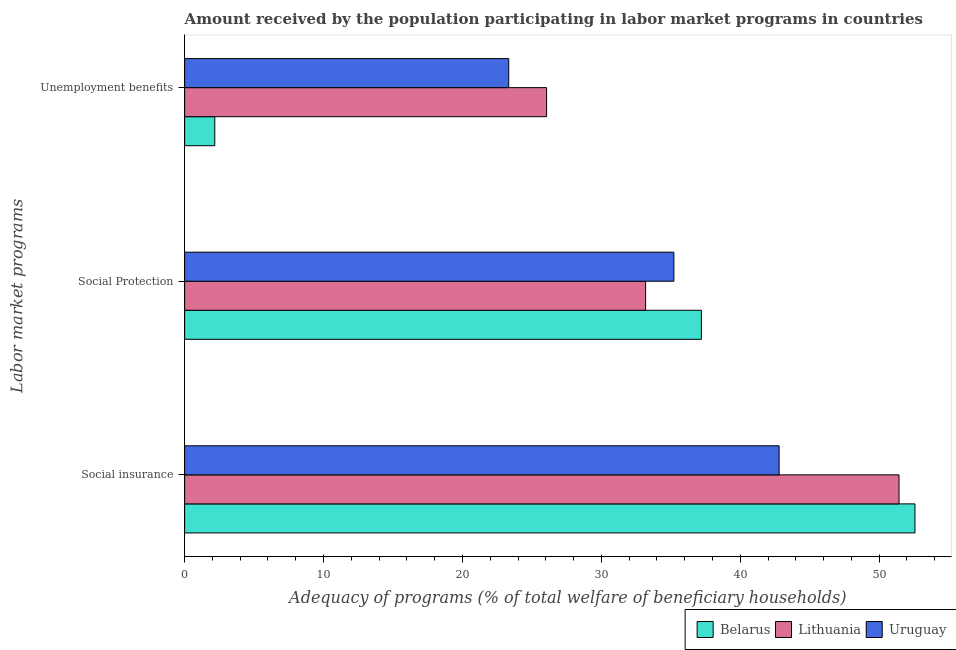How many different coloured bars are there?
Your response must be concise. 3. Are the number of bars per tick equal to the number of legend labels?
Your answer should be very brief. Yes. Are the number of bars on each tick of the Y-axis equal?
Make the answer very short. Yes. How many bars are there on the 2nd tick from the top?
Your answer should be compact. 3. What is the label of the 1st group of bars from the top?
Provide a short and direct response. Unemployment benefits. What is the amount received by the population participating in unemployment benefits programs in Belarus?
Your answer should be very brief. 2.17. Across all countries, what is the maximum amount received by the population participating in social protection programs?
Keep it short and to the point. 37.2. Across all countries, what is the minimum amount received by the population participating in social protection programs?
Offer a terse response. 33.19. In which country was the amount received by the population participating in social insurance programs maximum?
Keep it short and to the point. Belarus. In which country was the amount received by the population participating in social protection programs minimum?
Offer a terse response. Lithuania. What is the total amount received by the population participating in social protection programs in the graph?
Offer a terse response. 105.61. What is the difference between the amount received by the population participating in unemployment benefits programs in Belarus and that in Uruguay?
Ensure brevity in your answer.  -21.16. What is the difference between the amount received by the population participating in unemployment benefits programs in Lithuania and the amount received by the population participating in social insurance programs in Uruguay?
Your answer should be very brief. -16.74. What is the average amount received by the population participating in social protection programs per country?
Make the answer very short. 35.2. What is the difference between the amount received by the population participating in social insurance programs and amount received by the population participating in unemployment benefits programs in Lithuania?
Provide a short and direct response. 25.37. What is the ratio of the amount received by the population participating in social protection programs in Uruguay to that in Lithuania?
Your response must be concise. 1.06. Is the difference between the amount received by the population participating in social insurance programs in Belarus and Uruguay greater than the difference between the amount received by the population participating in unemployment benefits programs in Belarus and Uruguay?
Your response must be concise. Yes. What is the difference between the highest and the second highest amount received by the population participating in social insurance programs?
Provide a succinct answer. 1.15. What is the difference between the highest and the lowest amount received by the population participating in unemployment benefits programs?
Your answer should be compact. 23.89. In how many countries, is the amount received by the population participating in social insurance programs greater than the average amount received by the population participating in social insurance programs taken over all countries?
Offer a very short reply. 2. What does the 1st bar from the top in Social insurance represents?
Make the answer very short. Uruguay. What does the 3rd bar from the bottom in Social insurance represents?
Your answer should be very brief. Uruguay. Is it the case that in every country, the sum of the amount received by the population participating in social insurance programs and amount received by the population participating in social protection programs is greater than the amount received by the population participating in unemployment benefits programs?
Offer a terse response. Yes. Are all the bars in the graph horizontal?
Your answer should be very brief. Yes. What is the difference between two consecutive major ticks on the X-axis?
Ensure brevity in your answer.  10. Does the graph contain any zero values?
Your answer should be compact. No. How many legend labels are there?
Make the answer very short. 3. How are the legend labels stacked?
Provide a succinct answer. Horizontal. What is the title of the graph?
Your answer should be compact. Amount received by the population participating in labor market programs in countries. Does "OECD members" appear as one of the legend labels in the graph?
Keep it short and to the point. No. What is the label or title of the X-axis?
Your response must be concise. Adequacy of programs (% of total welfare of beneficiary households). What is the label or title of the Y-axis?
Your response must be concise. Labor market programs. What is the Adequacy of programs (% of total welfare of beneficiary households) in Belarus in Social insurance?
Offer a very short reply. 52.58. What is the Adequacy of programs (% of total welfare of beneficiary households) of Lithuania in Social insurance?
Ensure brevity in your answer.  51.43. What is the Adequacy of programs (% of total welfare of beneficiary households) of Uruguay in Social insurance?
Make the answer very short. 42.8. What is the Adequacy of programs (% of total welfare of beneficiary households) in Belarus in Social Protection?
Offer a very short reply. 37.2. What is the Adequacy of programs (% of total welfare of beneficiary households) of Lithuania in Social Protection?
Your response must be concise. 33.19. What is the Adequacy of programs (% of total welfare of beneficiary households) of Uruguay in Social Protection?
Provide a short and direct response. 35.22. What is the Adequacy of programs (% of total welfare of beneficiary households) of Belarus in Unemployment benefits?
Your answer should be very brief. 2.17. What is the Adequacy of programs (% of total welfare of beneficiary households) in Lithuania in Unemployment benefits?
Provide a succinct answer. 26.06. What is the Adequacy of programs (% of total welfare of beneficiary households) in Uruguay in Unemployment benefits?
Ensure brevity in your answer.  23.33. Across all Labor market programs, what is the maximum Adequacy of programs (% of total welfare of beneficiary households) of Belarus?
Provide a short and direct response. 52.58. Across all Labor market programs, what is the maximum Adequacy of programs (% of total welfare of beneficiary households) of Lithuania?
Your answer should be compact. 51.43. Across all Labor market programs, what is the maximum Adequacy of programs (% of total welfare of beneficiary households) in Uruguay?
Make the answer very short. 42.8. Across all Labor market programs, what is the minimum Adequacy of programs (% of total welfare of beneficiary households) in Belarus?
Give a very brief answer. 2.17. Across all Labor market programs, what is the minimum Adequacy of programs (% of total welfare of beneficiary households) in Lithuania?
Provide a succinct answer. 26.06. Across all Labor market programs, what is the minimum Adequacy of programs (% of total welfare of beneficiary households) of Uruguay?
Provide a succinct answer. 23.33. What is the total Adequacy of programs (% of total welfare of beneficiary households) in Belarus in the graph?
Your answer should be compact. 91.95. What is the total Adequacy of programs (% of total welfare of beneficiary households) of Lithuania in the graph?
Your response must be concise. 110.68. What is the total Adequacy of programs (% of total welfare of beneficiary households) in Uruguay in the graph?
Make the answer very short. 101.35. What is the difference between the Adequacy of programs (% of total welfare of beneficiary households) in Belarus in Social insurance and that in Social Protection?
Your answer should be compact. 15.38. What is the difference between the Adequacy of programs (% of total welfare of beneficiary households) of Lithuania in Social insurance and that in Social Protection?
Make the answer very short. 18.24. What is the difference between the Adequacy of programs (% of total welfare of beneficiary households) in Uruguay in Social insurance and that in Social Protection?
Make the answer very short. 7.58. What is the difference between the Adequacy of programs (% of total welfare of beneficiary households) of Belarus in Social insurance and that in Unemployment benefits?
Offer a very short reply. 50.41. What is the difference between the Adequacy of programs (% of total welfare of beneficiary households) of Lithuania in Social insurance and that in Unemployment benefits?
Ensure brevity in your answer.  25.37. What is the difference between the Adequacy of programs (% of total welfare of beneficiary households) in Uruguay in Social insurance and that in Unemployment benefits?
Your answer should be very brief. 19.47. What is the difference between the Adequacy of programs (% of total welfare of beneficiary households) of Belarus in Social Protection and that in Unemployment benefits?
Ensure brevity in your answer.  35.03. What is the difference between the Adequacy of programs (% of total welfare of beneficiary households) of Lithuania in Social Protection and that in Unemployment benefits?
Your response must be concise. 7.13. What is the difference between the Adequacy of programs (% of total welfare of beneficiary households) in Uruguay in Social Protection and that in Unemployment benefits?
Offer a terse response. 11.89. What is the difference between the Adequacy of programs (% of total welfare of beneficiary households) in Belarus in Social insurance and the Adequacy of programs (% of total welfare of beneficiary households) in Lithuania in Social Protection?
Provide a succinct answer. 19.39. What is the difference between the Adequacy of programs (% of total welfare of beneficiary households) in Belarus in Social insurance and the Adequacy of programs (% of total welfare of beneficiary households) in Uruguay in Social Protection?
Ensure brevity in your answer.  17.36. What is the difference between the Adequacy of programs (% of total welfare of beneficiary households) in Lithuania in Social insurance and the Adequacy of programs (% of total welfare of beneficiary households) in Uruguay in Social Protection?
Keep it short and to the point. 16.21. What is the difference between the Adequacy of programs (% of total welfare of beneficiary households) of Belarus in Social insurance and the Adequacy of programs (% of total welfare of beneficiary households) of Lithuania in Unemployment benefits?
Offer a very short reply. 26.52. What is the difference between the Adequacy of programs (% of total welfare of beneficiary households) of Belarus in Social insurance and the Adequacy of programs (% of total welfare of beneficiary households) of Uruguay in Unemployment benefits?
Your answer should be compact. 29.25. What is the difference between the Adequacy of programs (% of total welfare of beneficiary households) in Lithuania in Social insurance and the Adequacy of programs (% of total welfare of beneficiary households) in Uruguay in Unemployment benefits?
Ensure brevity in your answer.  28.1. What is the difference between the Adequacy of programs (% of total welfare of beneficiary households) in Belarus in Social Protection and the Adequacy of programs (% of total welfare of beneficiary households) in Lithuania in Unemployment benefits?
Offer a terse response. 11.14. What is the difference between the Adequacy of programs (% of total welfare of beneficiary households) in Belarus in Social Protection and the Adequacy of programs (% of total welfare of beneficiary households) in Uruguay in Unemployment benefits?
Offer a very short reply. 13.87. What is the difference between the Adequacy of programs (% of total welfare of beneficiary households) in Lithuania in Social Protection and the Adequacy of programs (% of total welfare of beneficiary households) in Uruguay in Unemployment benefits?
Give a very brief answer. 9.85. What is the average Adequacy of programs (% of total welfare of beneficiary households) of Belarus per Labor market programs?
Make the answer very short. 30.65. What is the average Adequacy of programs (% of total welfare of beneficiary households) of Lithuania per Labor market programs?
Offer a terse response. 36.89. What is the average Adequacy of programs (% of total welfare of beneficiary households) in Uruguay per Labor market programs?
Provide a short and direct response. 33.78. What is the difference between the Adequacy of programs (% of total welfare of beneficiary households) of Belarus and Adequacy of programs (% of total welfare of beneficiary households) of Lithuania in Social insurance?
Ensure brevity in your answer.  1.15. What is the difference between the Adequacy of programs (% of total welfare of beneficiary households) of Belarus and Adequacy of programs (% of total welfare of beneficiary households) of Uruguay in Social insurance?
Offer a terse response. 9.78. What is the difference between the Adequacy of programs (% of total welfare of beneficiary households) in Lithuania and Adequacy of programs (% of total welfare of beneficiary households) in Uruguay in Social insurance?
Your answer should be very brief. 8.63. What is the difference between the Adequacy of programs (% of total welfare of beneficiary households) in Belarus and Adequacy of programs (% of total welfare of beneficiary households) in Lithuania in Social Protection?
Your response must be concise. 4.01. What is the difference between the Adequacy of programs (% of total welfare of beneficiary households) in Belarus and Adequacy of programs (% of total welfare of beneficiary households) in Uruguay in Social Protection?
Provide a succinct answer. 1.98. What is the difference between the Adequacy of programs (% of total welfare of beneficiary households) of Lithuania and Adequacy of programs (% of total welfare of beneficiary households) of Uruguay in Social Protection?
Keep it short and to the point. -2.03. What is the difference between the Adequacy of programs (% of total welfare of beneficiary households) of Belarus and Adequacy of programs (% of total welfare of beneficiary households) of Lithuania in Unemployment benefits?
Make the answer very short. -23.89. What is the difference between the Adequacy of programs (% of total welfare of beneficiary households) of Belarus and Adequacy of programs (% of total welfare of beneficiary households) of Uruguay in Unemployment benefits?
Your answer should be very brief. -21.16. What is the difference between the Adequacy of programs (% of total welfare of beneficiary households) of Lithuania and Adequacy of programs (% of total welfare of beneficiary households) of Uruguay in Unemployment benefits?
Provide a short and direct response. 2.73. What is the ratio of the Adequacy of programs (% of total welfare of beneficiary households) in Belarus in Social insurance to that in Social Protection?
Provide a succinct answer. 1.41. What is the ratio of the Adequacy of programs (% of total welfare of beneficiary households) of Lithuania in Social insurance to that in Social Protection?
Make the answer very short. 1.55. What is the ratio of the Adequacy of programs (% of total welfare of beneficiary households) in Uruguay in Social insurance to that in Social Protection?
Provide a succinct answer. 1.22. What is the ratio of the Adequacy of programs (% of total welfare of beneficiary households) in Belarus in Social insurance to that in Unemployment benefits?
Your response must be concise. 24.23. What is the ratio of the Adequacy of programs (% of total welfare of beneficiary households) in Lithuania in Social insurance to that in Unemployment benefits?
Give a very brief answer. 1.97. What is the ratio of the Adequacy of programs (% of total welfare of beneficiary households) in Uruguay in Social insurance to that in Unemployment benefits?
Keep it short and to the point. 1.83. What is the ratio of the Adequacy of programs (% of total welfare of beneficiary households) in Belarus in Social Protection to that in Unemployment benefits?
Provide a succinct answer. 17.14. What is the ratio of the Adequacy of programs (% of total welfare of beneficiary households) in Lithuania in Social Protection to that in Unemployment benefits?
Provide a short and direct response. 1.27. What is the ratio of the Adequacy of programs (% of total welfare of beneficiary households) of Uruguay in Social Protection to that in Unemployment benefits?
Your answer should be very brief. 1.51. What is the difference between the highest and the second highest Adequacy of programs (% of total welfare of beneficiary households) in Belarus?
Ensure brevity in your answer.  15.38. What is the difference between the highest and the second highest Adequacy of programs (% of total welfare of beneficiary households) in Lithuania?
Your response must be concise. 18.24. What is the difference between the highest and the second highest Adequacy of programs (% of total welfare of beneficiary households) of Uruguay?
Provide a succinct answer. 7.58. What is the difference between the highest and the lowest Adequacy of programs (% of total welfare of beneficiary households) of Belarus?
Your response must be concise. 50.41. What is the difference between the highest and the lowest Adequacy of programs (% of total welfare of beneficiary households) in Lithuania?
Provide a succinct answer. 25.37. What is the difference between the highest and the lowest Adequacy of programs (% of total welfare of beneficiary households) of Uruguay?
Give a very brief answer. 19.47. 